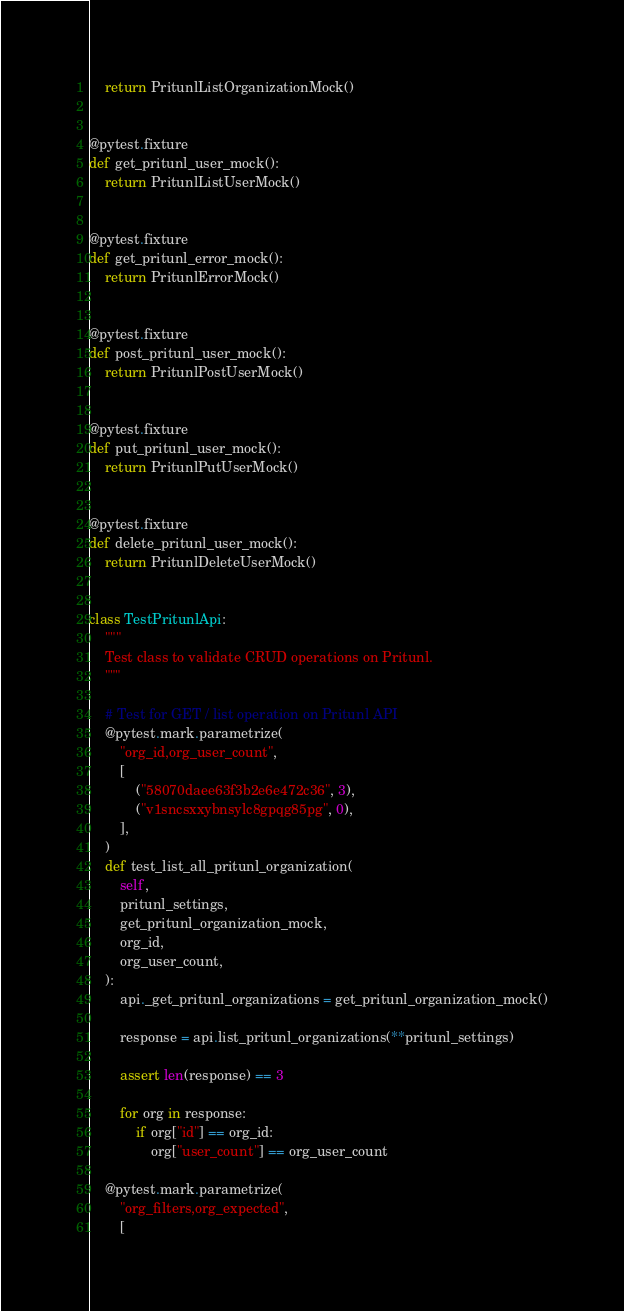<code> <loc_0><loc_0><loc_500><loc_500><_Python_>    return PritunlListOrganizationMock()


@pytest.fixture
def get_pritunl_user_mock():
    return PritunlListUserMock()


@pytest.fixture
def get_pritunl_error_mock():
    return PritunlErrorMock()


@pytest.fixture
def post_pritunl_user_mock():
    return PritunlPostUserMock()


@pytest.fixture
def put_pritunl_user_mock():
    return PritunlPutUserMock()


@pytest.fixture
def delete_pritunl_user_mock():
    return PritunlDeleteUserMock()


class TestPritunlApi:
    """
    Test class to validate CRUD operations on Pritunl.
    """

    # Test for GET / list operation on Pritunl API
    @pytest.mark.parametrize(
        "org_id,org_user_count",
        [
            ("58070daee63f3b2e6e472c36", 3),
            ("v1sncsxxybnsylc8gpqg85pg", 0),
        ],
    )
    def test_list_all_pritunl_organization(
        self,
        pritunl_settings,
        get_pritunl_organization_mock,
        org_id,
        org_user_count,
    ):
        api._get_pritunl_organizations = get_pritunl_organization_mock()

        response = api.list_pritunl_organizations(**pritunl_settings)

        assert len(response) == 3

        for org in response:
            if org["id"] == org_id:
                org["user_count"] == org_user_count

    @pytest.mark.parametrize(
        "org_filters,org_expected",
        [</code> 